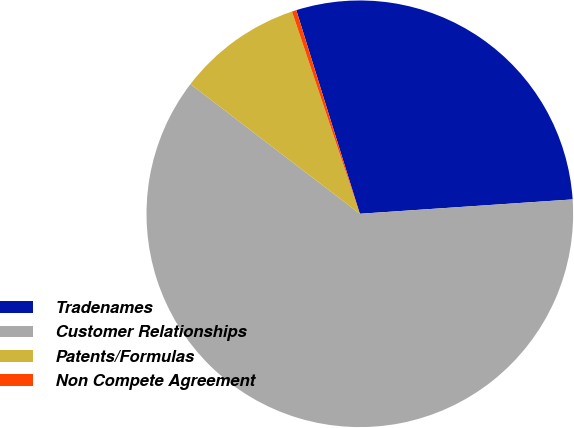Convert chart to OTSL. <chart><loc_0><loc_0><loc_500><loc_500><pie_chart><fcel>Tradenames<fcel>Customer Relationships<fcel>Patents/Formulas<fcel>Non Compete Agreement<nl><fcel>28.74%<fcel>61.47%<fcel>9.45%<fcel>0.34%<nl></chart> 